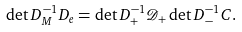Convert formula to latex. <formula><loc_0><loc_0><loc_500><loc_500>\det D _ { M } ^ { - 1 } D _ { e } = \det D _ { + } ^ { - 1 } \mathcal { D } _ { + } \det D _ { - } ^ { - 1 } C .</formula> 